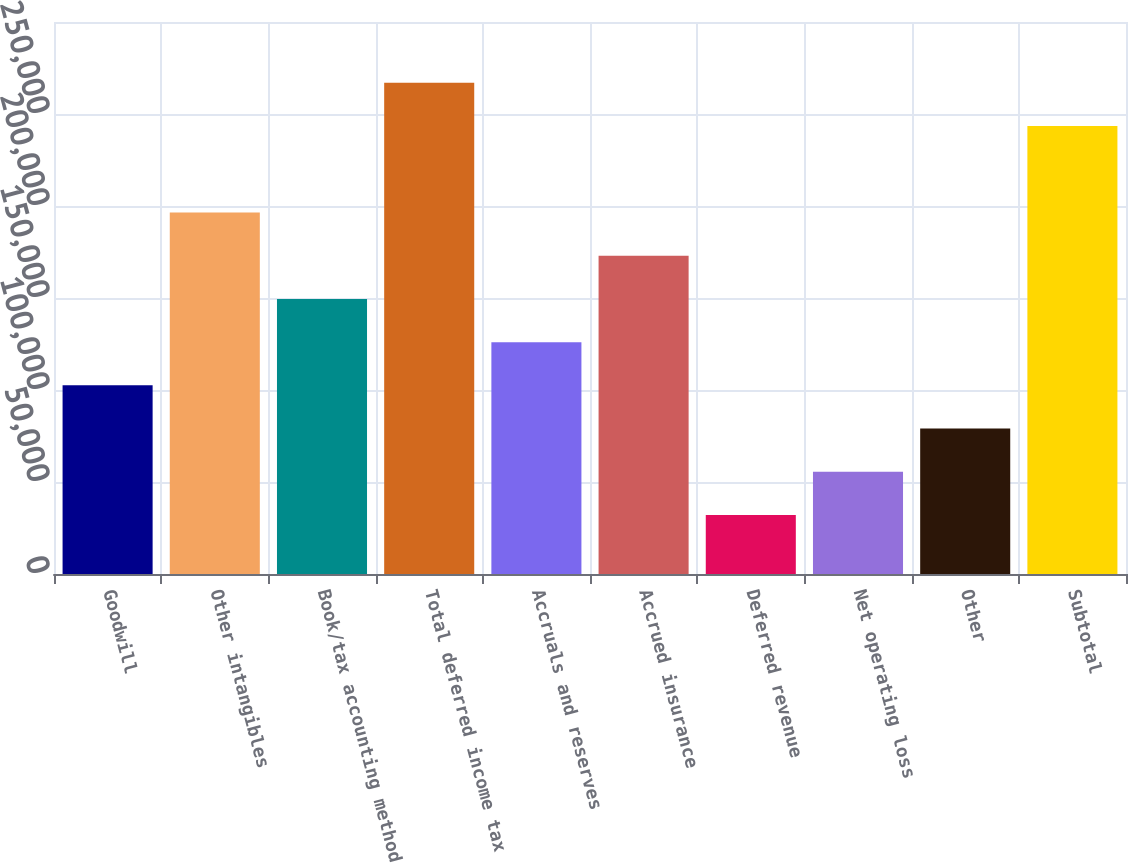Convert chart. <chart><loc_0><loc_0><loc_500><loc_500><bar_chart><fcel>Goodwill<fcel>Other intangibles<fcel>Book/tax accounting method<fcel>Total deferred income tax<fcel>Accruals and reserves<fcel>Accrued insurance<fcel>Deferred revenue<fcel>Net operating loss<fcel>Other<fcel>Subtotal<nl><fcel>102515<fcel>196468<fcel>149492<fcel>266933<fcel>126004<fcel>172980<fcel>32050.3<fcel>55538.6<fcel>79026.9<fcel>243445<nl></chart> 